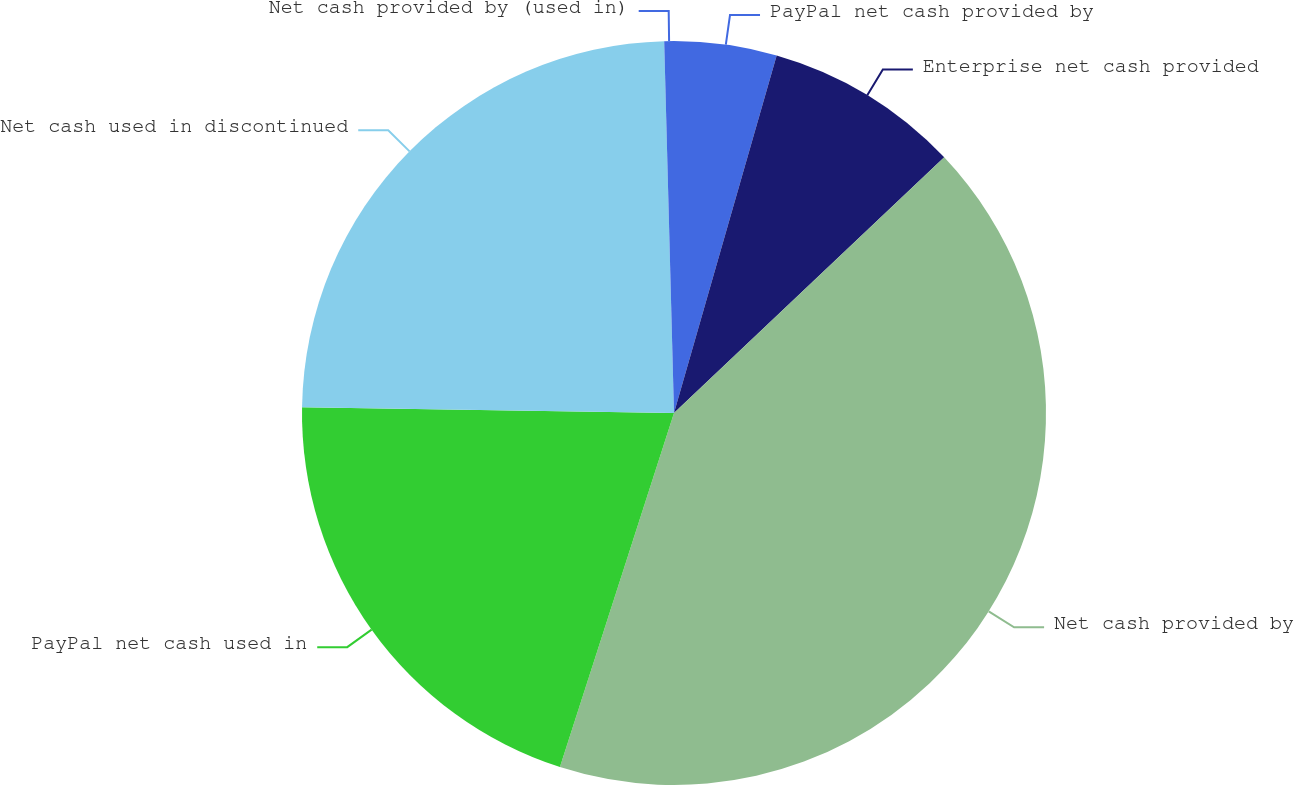Convert chart. <chart><loc_0><loc_0><loc_500><loc_500><pie_chart><fcel>PayPal net cash provided by<fcel>Enterprise net cash provided<fcel>Net cash provided by<fcel>PayPal net cash used in<fcel>Net cash used in discontinued<fcel>Net cash provided by (used in)<nl><fcel>4.45%<fcel>8.49%<fcel>42.02%<fcel>20.29%<fcel>24.33%<fcel>0.42%<nl></chart> 